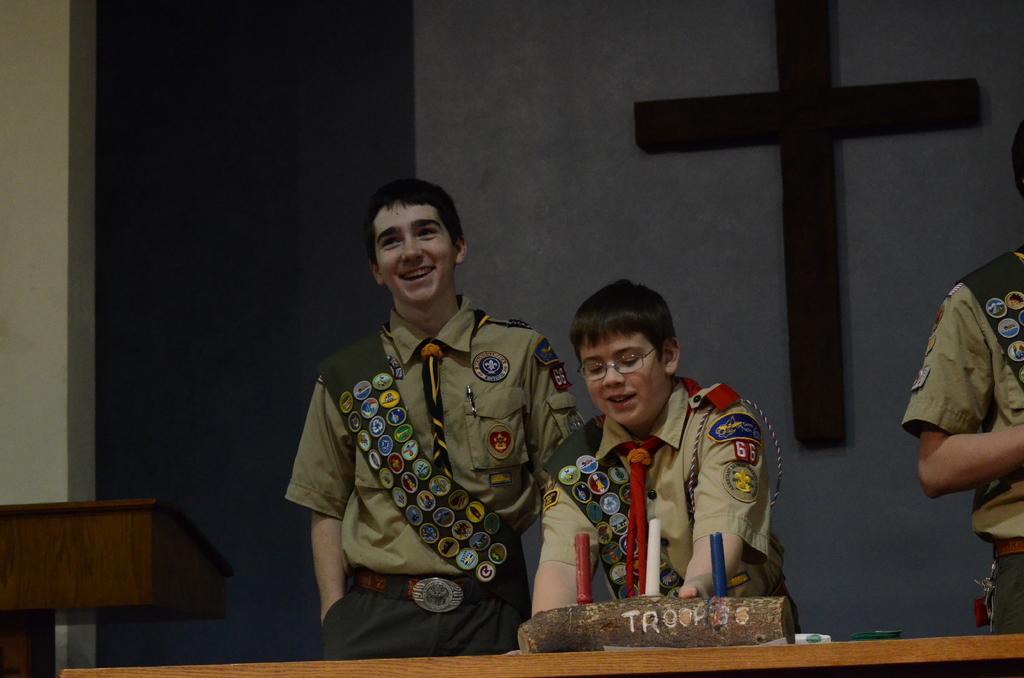How would you summarize this image in a sentence or two? In this image there is a table on which a stick is placed there are two boys standing and one boy is smiling beside him there is a table in the background a sign place on the wall and the wall is in white color, 